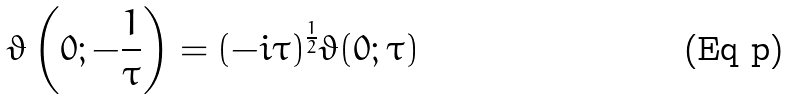<formula> <loc_0><loc_0><loc_500><loc_500>\vartheta \left ( 0 ; - { \frac { 1 } { \tau } } \right ) = ( - i \tau ) ^ { \frac { 1 } { 2 } } \vartheta ( 0 ; \tau )</formula> 